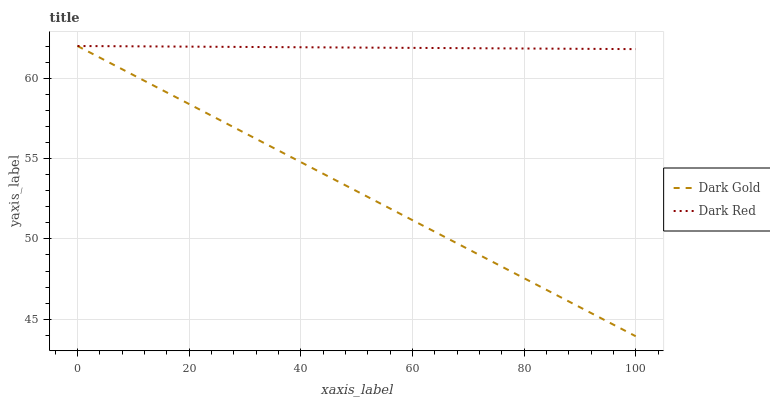Does Dark Gold have the maximum area under the curve?
Answer yes or no. No. Is Dark Gold the smoothest?
Answer yes or no. No. 